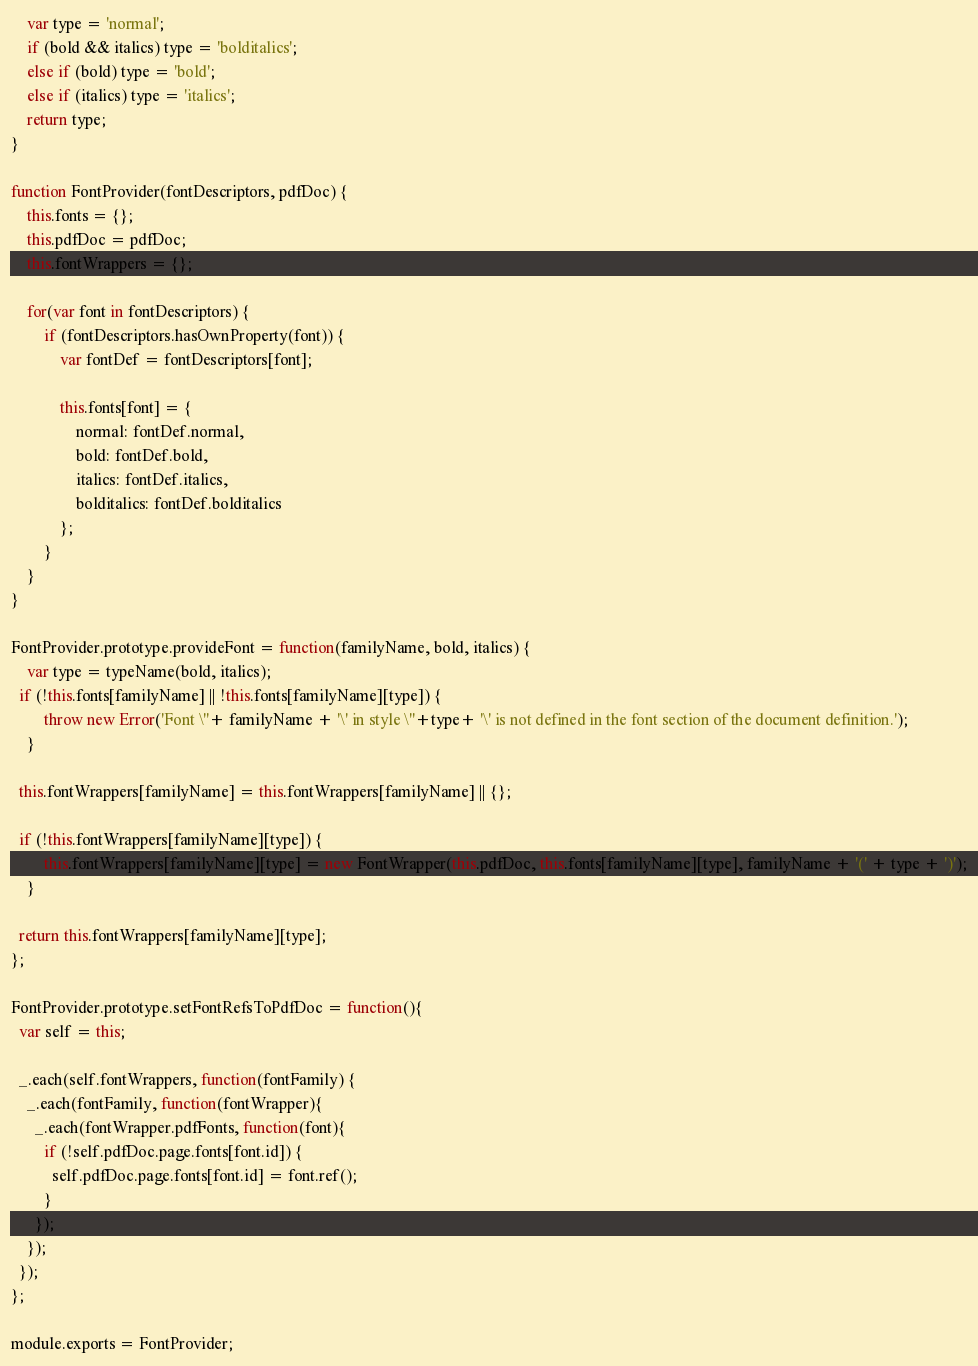Convert code to text. <code><loc_0><loc_0><loc_500><loc_500><_JavaScript_>	var type = 'normal';
	if (bold && italics) type = 'bolditalics';
	else if (bold) type = 'bold';
	else if (italics) type = 'italics';
	return type;
}

function FontProvider(fontDescriptors, pdfDoc) {
	this.fonts = {};
	this.pdfDoc = pdfDoc;
	this.fontWrappers = {};

	for(var font in fontDescriptors) {
		if (fontDescriptors.hasOwnProperty(font)) {
			var fontDef = fontDescriptors[font];

			this.fonts[font] = {
				normal: fontDef.normal,
				bold: fontDef.bold,
				italics: fontDef.italics,
				bolditalics: fontDef.bolditalics
			};
		}
	}
}

FontProvider.prototype.provideFont = function(familyName, bold, italics) {
	var type = typeName(bold, italics);
  if (!this.fonts[familyName] || !this.fonts[familyName][type]) {
		throw new Error('Font \''+ familyName + '\' in style \''+type+ '\' is not defined in the font section of the document definition.');
	}

  this.fontWrappers[familyName] = this.fontWrappers[familyName] || {};

  if (!this.fontWrappers[familyName][type]) {
		this.fontWrappers[familyName][type] = new FontWrapper(this.pdfDoc, this.fonts[familyName][type], familyName + '(' + type + ')');
	}

  return this.fontWrappers[familyName][type];
};

FontProvider.prototype.setFontRefsToPdfDoc = function(){
  var self = this;

  _.each(self.fontWrappers, function(fontFamily) {
    _.each(fontFamily, function(fontWrapper){
      _.each(fontWrapper.pdfFonts, function(font){
        if (!self.pdfDoc.page.fonts[font.id]) {
          self.pdfDoc.page.fonts[font.id] = font.ref();
        }
      });
    });
  });
};

module.exports = FontProvider;
</code> 